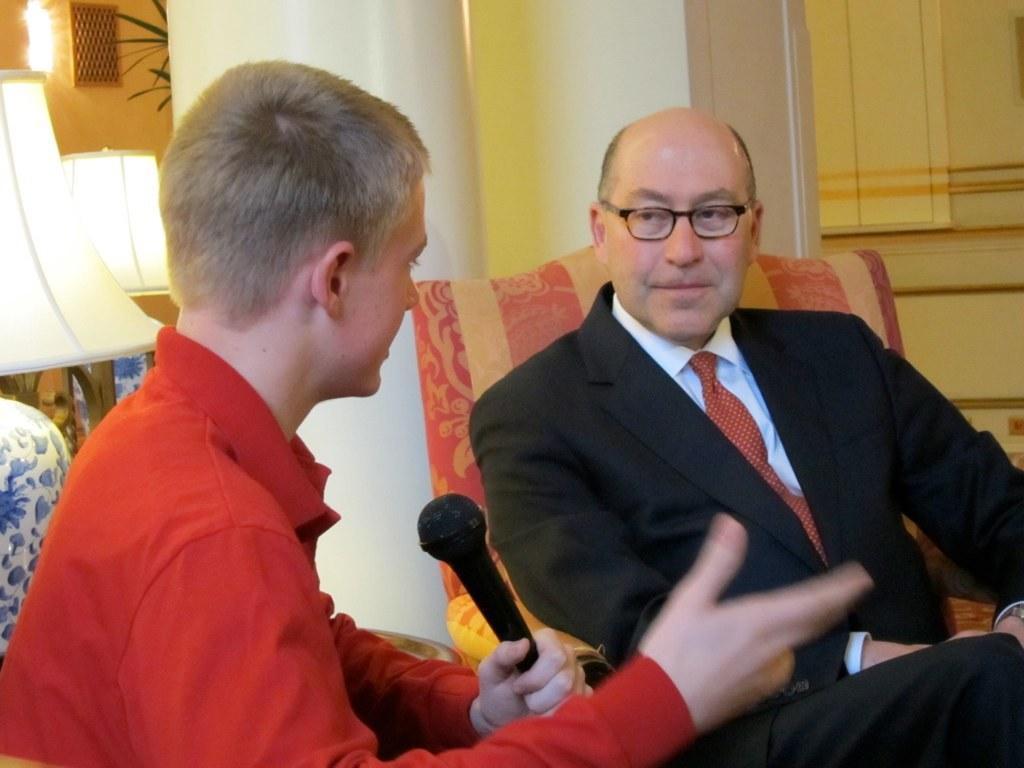How would you summarize this image in a sentence or two? In the picture we can see a man sitting in the chair and interviewing a person in front of him, the interviewer is asking something holding a microphone and opposite man is in black color blazer, tie and shirt and behind him we can see a pillar and behind it, we can see some lamps, and a light to the wall and beside it we can see a part of the leaves behind the pillar. 